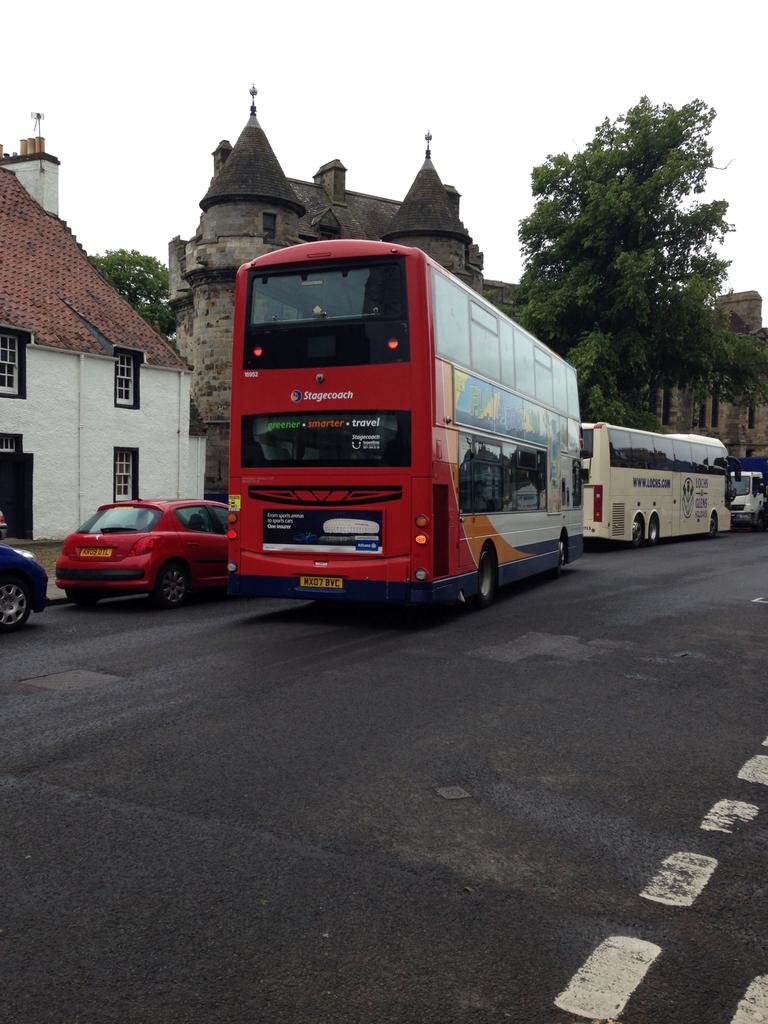What is the slogan of the bus company?
Provide a succinct answer. Unanswerable. Is this a stagecoach bus?
Provide a short and direct response. Yes. 